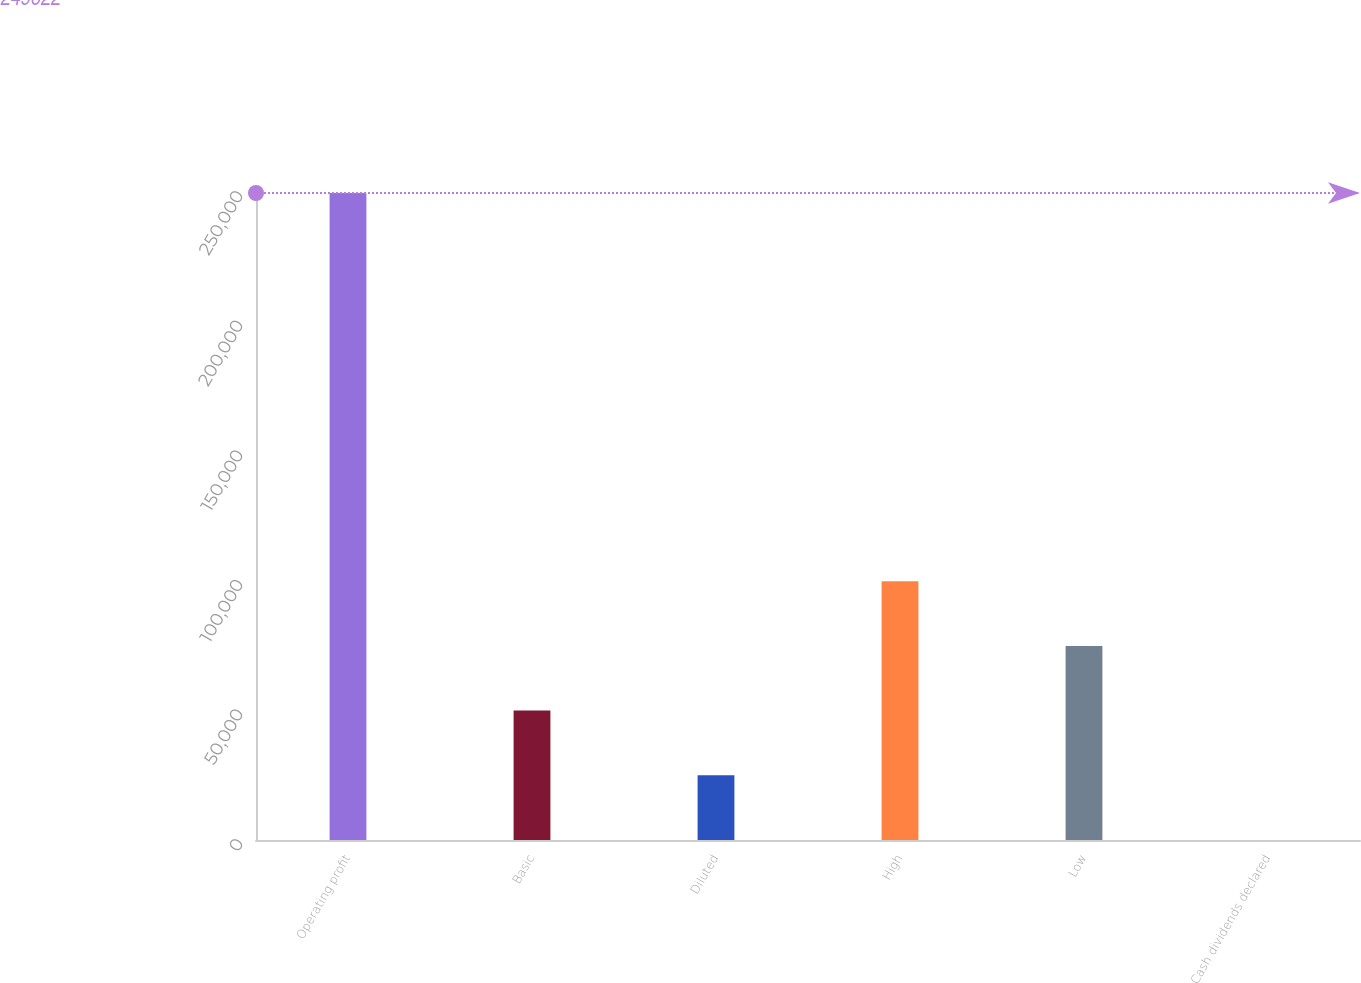Convert chart to OTSL. <chart><loc_0><loc_0><loc_500><loc_500><bar_chart><fcel>Operating profit<fcel>Basic<fcel>Diluted<fcel>High<fcel>Low<fcel>Cash dividends declared<nl><fcel>249622<fcel>49924.7<fcel>24962.5<fcel>99849<fcel>74886.8<fcel>0.36<nl></chart> 